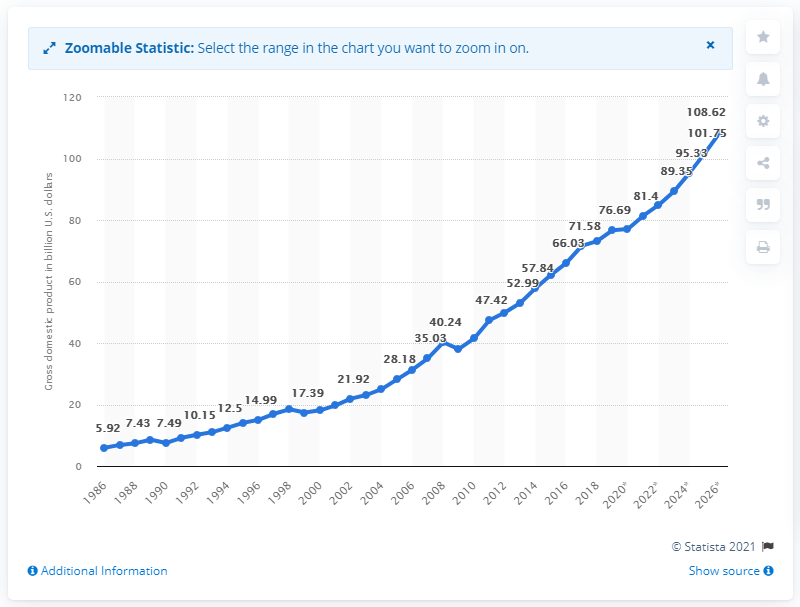Specify some key components in this picture. In 2019, Guatemala's gross domestic product (GDP) was 77.07. 